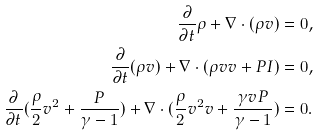Convert formula to latex. <formula><loc_0><loc_0><loc_500><loc_500>\frac { \partial } { \partial t } \rho + \nabla \cdot ( \rho v ) & = 0 , \\ \frac { \partial } { \partial t } ( \rho v ) + \nabla \cdot ( \rho v v + P I ) & = 0 , \\ \frac { \partial } { \partial t } ( \frac { \rho } { 2 } v ^ { 2 } + \frac { P } { \gamma - 1 } ) + \nabla \cdot ( \frac { \rho } { 2 } v ^ { 2 } v + \frac { \gamma v P } { \gamma - 1 } ) & = 0 .</formula> 